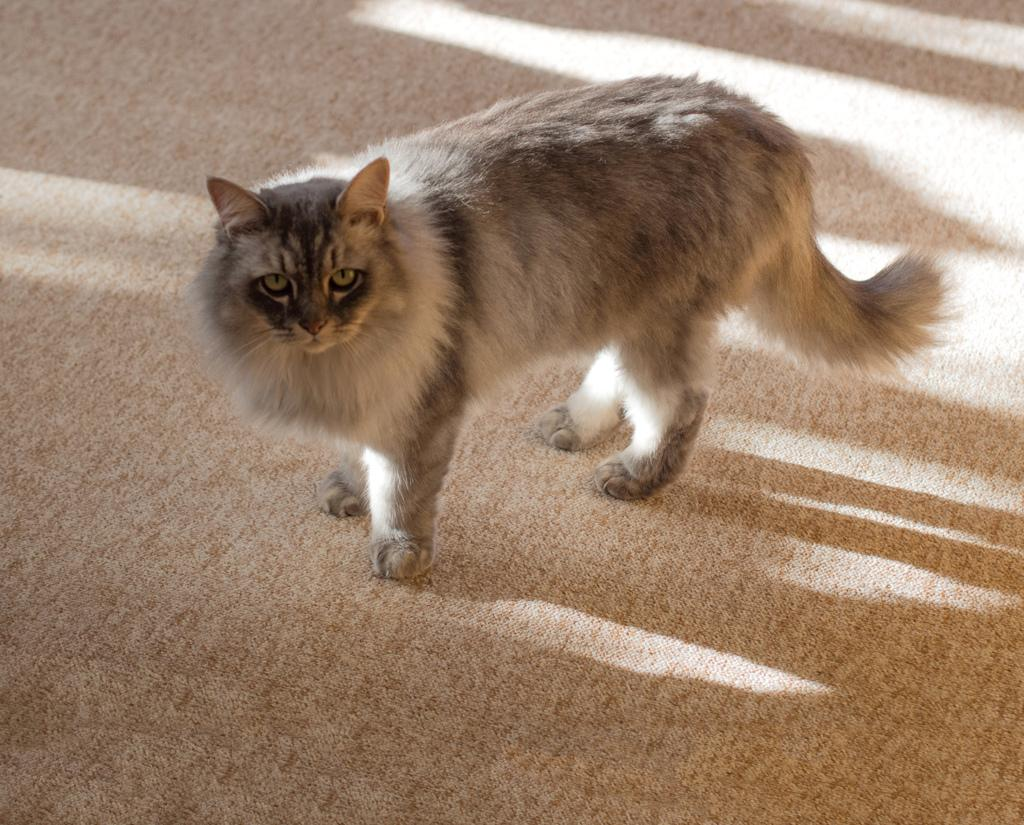What type of animal is in the image? There is a cat in the image. What surface is the cat standing on? The cat is standing on a carpet. What type of canvas is the cat using to paint in the image? There is no canvas or painting activity present in the image; it features a cat standing on a carpet. 